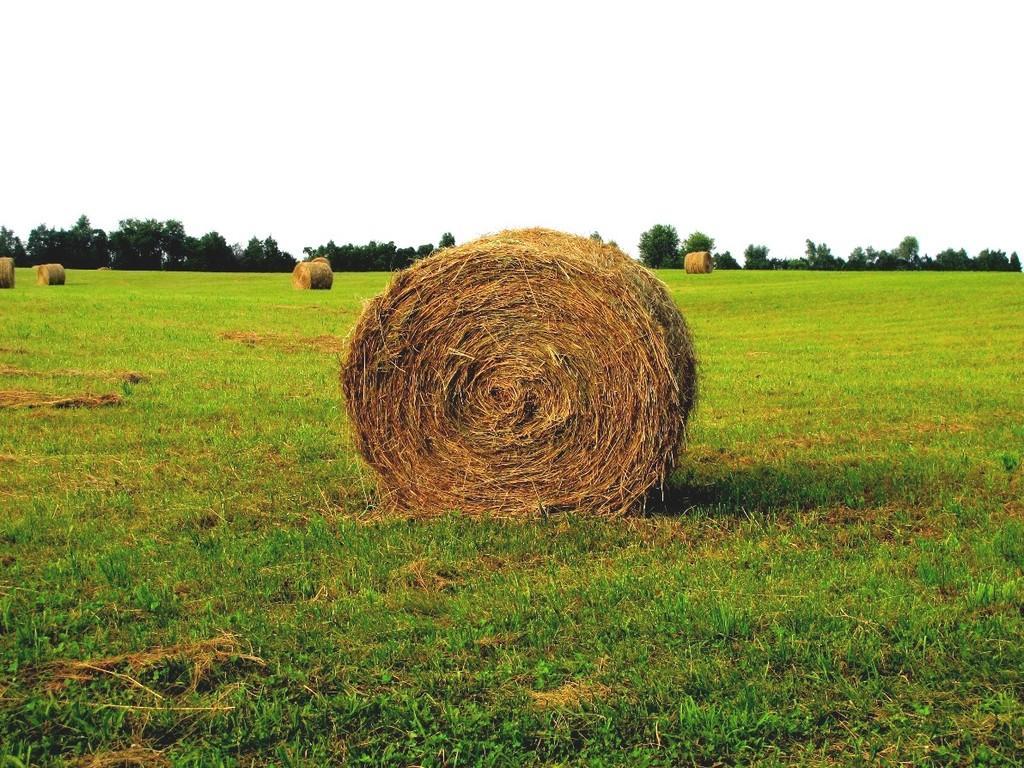Can you describe this image briefly? In this image we can see ground, grass, and trees. In the background there is sky. 